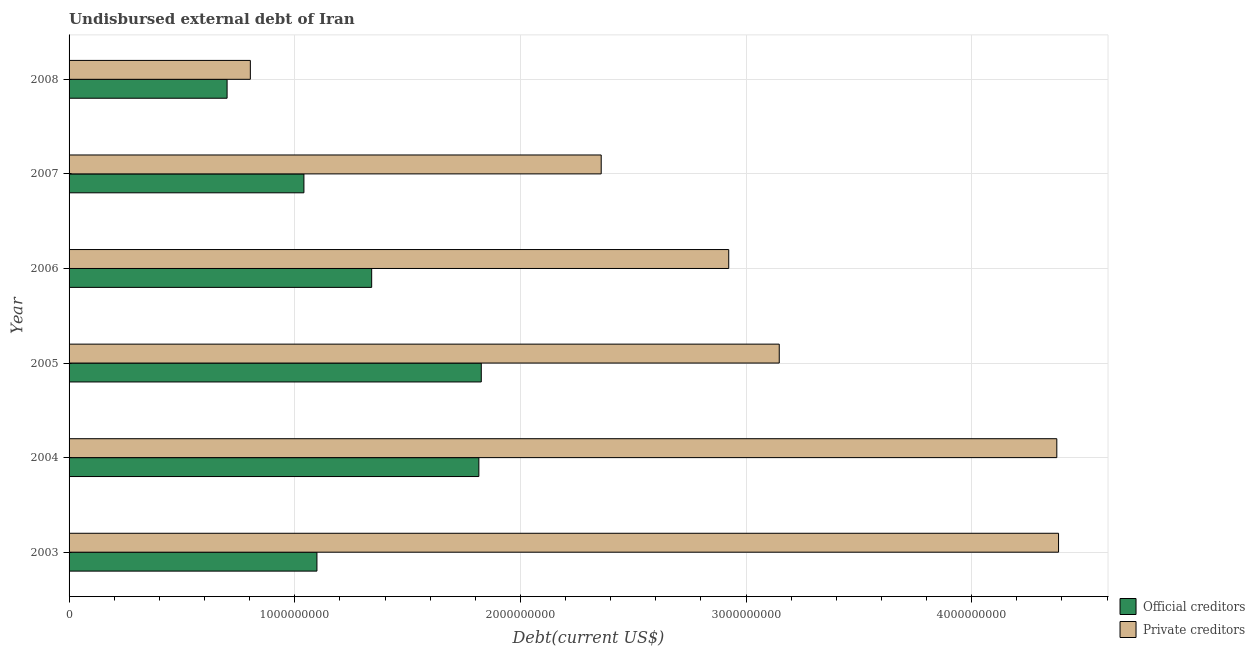How many different coloured bars are there?
Keep it short and to the point. 2. How many groups of bars are there?
Your answer should be compact. 6. Are the number of bars per tick equal to the number of legend labels?
Ensure brevity in your answer.  Yes. Are the number of bars on each tick of the Y-axis equal?
Ensure brevity in your answer.  Yes. How many bars are there on the 4th tick from the top?
Give a very brief answer. 2. What is the label of the 6th group of bars from the top?
Your answer should be compact. 2003. In how many cases, is the number of bars for a given year not equal to the number of legend labels?
Provide a succinct answer. 0. What is the undisbursed external debt of private creditors in 2007?
Ensure brevity in your answer.  2.36e+09. Across all years, what is the maximum undisbursed external debt of official creditors?
Give a very brief answer. 1.83e+09. Across all years, what is the minimum undisbursed external debt of private creditors?
Keep it short and to the point. 8.03e+08. What is the total undisbursed external debt of official creditors in the graph?
Your answer should be very brief. 7.82e+09. What is the difference between the undisbursed external debt of private creditors in 2006 and that in 2008?
Provide a succinct answer. 2.12e+09. What is the difference between the undisbursed external debt of official creditors in 2006 and the undisbursed external debt of private creditors in 2008?
Your answer should be very brief. 5.38e+08. What is the average undisbursed external debt of official creditors per year?
Your answer should be compact. 1.30e+09. In the year 2007, what is the difference between the undisbursed external debt of official creditors and undisbursed external debt of private creditors?
Ensure brevity in your answer.  -1.32e+09. In how many years, is the undisbursed external debt of official creditors greater than 800000000 US$?
Your response must be concise. 5. What is the ratio of the undisbursed external debt of official creditors in 2006 to that in 2008?
Provide a succinct answer. 1.92. Is the undisbursed external debt of private creditors in 2003 less than that in 2004?
Ensure brevity in your answer.  No. Is the difference between the undisbursed external debt of official creditors in 2005 and 2006 greater than the difference between the undisbursed external debt of private creditors in 2005 and 2006?
Offer a terse response. Yes. What is the difference between the highest and the second highest undisbursed external debt of official creditors?
Keep it short and to the point. 1.07e+07. What is the difference between the highest and the lowest undisbursed external debt of official creditors?
Your response must be concise. 1.13e+09. What does the 1st bar from the top in 2005 represents?
Offer a terse response. Private creditors. What does the 1st bar from the bottom in 2008 represents?
Offer a terse response. Official creditors. How many bars are there?
Make the answer very short. 12. Are all the bars in the graph horizontal?
Offer a terse response. Yes. Are the values on the major ticks of X-axis written in scientific E-notation?
Your answer should be very brief. No. Does the graph contain grids?
Provide a short and direct response. Yes. Where does the legend appear in the graph?
Your response must be concise. Bottom right. How many legend labels are there?
Your answer should be very brief. 2. What is the title of the graph?
Ensure brevity in your answer.  Undisbursed external debt of Iran. Does "From production" appear as one of the legend labels in the graph?
Your response must be concise. No. What is the label or title of the X-axis?
Make the answer very short. Debt(current US$). What is the Debt(current US$) of Official creditors in 2003?
Offer a very short reply. 1.10e+09. What is the Debt(current US$) of Private creditors in 2003?
Offer a very short reply. 4.38e+09. What is the Debt(current US$) of Official creditors in 2004?
Your answer should be very brief. 1.82e+09. What is the Debt(current US$) of Private creditors in 2004?
Ensure brevity in your answer.  4.38e+09. What is the Debt(current US$) in Official creditors in 2005?
Your answer should be compact. 1.83e+09. What is the Debt(current US$) in Private creditors in 2005?
Provide a succinct answer. 3.15e+09. What is the Debt(current US$) of Official creditors in 2006?
Your answer should be very brief. 1.34e+09. What is the Debt(current US$) of Private creditors in 2006?
Give a very brief answer. 2.92e+09. What is the Debt(current US$) of Official creditors in 2007?
Your answer should be compact. 1.04e+09. What is the Debt(current US$) of Private creditors in 2007?
Your answer should be very brief. 2.36e+09. What is the Debt(current US$) in Official creditors in 2008?
Make the answer very short. 7.00e+08. What is the Debt(current US$) of Private creditors in 2008?
Provide a short and direct response. 8.03e+08. Across all years, what is the maximum Debt(current US$) of Official creditors?
Your response must be concise. 1.83e+09. Across all years, what is the maximum Debt(current US$) of Private creditors?
Your answer should be compact. 4.38e+09. Across all years, what is the minimum Debt(current US$) in Official creditors?
Offer a very short reply. 7.00e+08. Across all years, what is the minimum Debt(current US$) in Private creditors?
Your response must be concise. 8.03e+08. What is the total Debt(current US$) of Official creditors in the graph?
Ensure brevity in your answer.  7.82e+09. What is the total Debt(current US$) of Private creditors in the graph?
Provide a succinct answer. 1.80e+1. What is the difference between the Debt(current US$) of Official creditors in 2003 and that in 2004?
Provide a succinct answer. -7.18e+08. What is the difference between the Debt(current US$) in Private creditors in 2003 and that in 2004?
Give a very brief answer. 7.67e+06. What is the difference between the Debt(current US$) of Official creditors in 2003 and that in 2005?
Your response must be concise. -7.28e+08. What is the difference between the Debt(current US$) of Private creditors in 2003 and that in 2005?
Provide a short and direct response. 1.24e+09. What is the difference between the Debt(current US$) of Official creditors in 2003 and that in 2006?
Your response must be concise. -2.43e+08. What is the difference between the Debt(current US$) in Private creditors in 2003 and that in 2006?
Your response must be concise. 1.46e+09. What is the difference between the Debt(current US$) of Official creditors in 2003 and that in 2007?
Provide a short and direct response. 5.76e+07. What is the difference between the Debt(current US$) in Private creditors in 2003 and that in 2007?
Your response must be concise. 2.03e+09. What is the difference between the Debt(current US$) in Official creditors in 2003 and that in 2008?
Your answer should be compact. 3.98e+08. What is the difference between the Debt(current US$) in Private creditors in 2003 and that in 2008?
Provide a succinct answer. 3.58e+09. What is the difference between the Debt(current US$) in Official creditors in 2004 and that in 2005?
Keep it short and to the point. -1.07e+07. What is the difference between the Debt(current US$) in Private creditors in 2004 and that in 2005?
Your answer should be compact. 1.23e+09. What is the difference between the Debt(current US$) of Official creditors in 2004 and that in 2006?
Your answer should be compact. 4.75e+08. What is the difference between the Debt(current US$) of Private creditors in 2004 and that in 2006?
Your answer should be compact. 1.45e+09. What is the difference between the Debt(current US$) in Official creditors in 2004 and that in 2007?
Give a very brief answer. 7.75e+08. What is the difference between the Debt(current US$) of Private creditors in 2004 and that in 2007?
Keep it short and to the point. 2.02e+09. What is the difference between the Debt(current US$) in Official creditors in 2004 and that in 2008?
Provide a short and direct response. 1.12e+09. What is the difference between the Debt(current US$) in Private creditors in 2004 and that in 2008?
Your answer should be very brief. 3.57e+09. What is the difference between the Debt(current US$) in Official creditors in 2005 and that in 2006?
Offer a very short reply. 4.86e+08. What is the difference between the Debt(current US$) of Private creditors in 2005 and that in 2006?
Offer a very short reply. 2.24e+08. What is the difference between the Debt(current US$) of Official creditors in 2005 and that in 2007?
Your answer should be very brief. 7.86e+08. What is the difference between the Debt(current US$) of Private creditors in 2005 and that in 2007?
Your answer should be very brief. 7.89e+08. What is the difference between the Debt(current US$) of Official creditors in 2005 and that in 2008?
Your answer should be very brief. 1.13e+09. What is the difference between the Debt(current US$) in Private creditors in 2005 and that in 2008?
Provide a succinct answer. 2.34e+09. What is the difference between the Debt(current US$) in Official creditors in 2006 and that in 2007?
Your response must be concise. 3.00e+08. What is the difference between the Debt(current US$) of Private creditors in 2006 and that in 2007?
Your response must be concise. 5.65e+08. What is the difference between the Debt(current US$) of Official creditors in 2006 and that in 2008?
Make the answer very short. 6.41e+08. What is the difference between the Debt(current US$) of Private creditors in 2006 and that in 2008?
Your answer should be very brief. 2.12e+09. What is the difference between the Debt(current US$) in Official creditors in 2007 and that in 2008?
Give a very brief answer. 3.41e+08. What is the difference between the Debt(current US$) in Private creditors in 2007 and that in 2008?
Provide a succinct answer. 1.55e+09. What is the difference between the Debt(current US$) in Official creditors in 2003 and the Debt(current US$) in Private creditors in 2004?
Your answer should be compact. -3.28e+09. What is the difference between the Debt(current US$) in Official creditors in 2003 and the Debt(current US$) in Private creditors in 2005?
Make the answer very short. -2.05e+09. What is the difference between the Debt(current US$) in Official creditors in 2003 and the Debt(current US$) in Private creditors in 2006?
Provide a succinct answer. -1.82e+09. What is the difference between the Debt(current US$) of Official creditors in 2003 and the Debt(current US$) of Private creditors in 2007?
Your response must be concise. -1.26e+09. What is the difference between the Debt(current US$) in Official creditors in 2003 and the Debt(current US$) in Private creditors in 2008?
Your answer should be very brief. 2.95e+08. What is the difference between the Debt(current US$) in Official creditors in 2004 and the Debt(current US$) in Private creditors in 2005?
Provide a succinct answer. -1.33e+09. What is the difference between the Debt(current US$) of Official creditors in 2004 and the Debt(current US$) of Private creditors in 2006?
Your answer should be very brief. -1.11e+09. What is the difference between the Debt(current US$) of Official creditors in 2004 and the Debt(current US$) of Private creditors in 2007?
Your answer should be very brief. -5.42e+08. What is the difference between the Debt(current US$) of Official creditors in 2004 and the Debt(current US$) of Private creditors in 2008?
Provide a succinct answer. 1.01e+09. What is the difference between the Debt(current US$) of Official creditors in 2005 and the Debt(current US$) of Private creditors in 2006?
Make the answer very short. -1.10e+09. What is the difference between the Debt(current US$) of Official creditors in 2005 and the Debt(current US$) of Private creditors in 2007?
Give a very brief answer. -5.31e+08. What is the difference between the Debt(current US$) in Official creditors in 2005 and the Debt(current US$) in Private creditors in 2008?
Keep it short and to the point. 1.02e+09. What is the difference between the Debt(current US$) of Official creditors in 2006 and the Debt(current US$) of Private creditors in 2007?
Provide a short and direct response. -1.02e+09. What is the difference between the Debt(current US$) of Official creditors in 2006 and the Debt(current US$) of Private creditors in 2008?
Provide a succinct answer. 5.38e+08. What is the difference between the Debt(current US$) of Official creditors in 2007 and the Debt(current US$) of Private creditors in 2008?
Offer a terse response. 2.37e+08. What is the average Debt(current US$) in Official creditors per year?
Ensure brevity in your answer.  1.30e+09. What is the average Debt(current US$) in Private creditors per year?
Ensure brevity in your answer.  3.00e+09. In the year 2003, what is the difference between the Debt(current US$) of Official creditors and Debt(current US$) of Private creditors?
Make the answer very short. -3.29e+09. In the year 2004, what is the difference between the Debt(current US$) in Official creditors and Debt(current US$) in Private creditors?
Ensure brevity in your answer.  -2.56e+09. In the year 2005, what is the difference between the Debt(current US$) in Official creditors and Debt(current US$) in Private creditors?
Your answer should be very brief. -1.32e+09. In the year 2006, what is the difference between the Debt(current US$) in Official creditors and Debt(current US$) in Private creditors?
Give a very brief answer. -1.58e+09. In the year 2007, what is the difference between the Debt(current US$) in Official creditors and Debt(current US$) in Private creditors?
Your answer should be compact. -1.32e+09. In the year 2008, what is the difference between the Debt(current US$) in Official creditors and Debt(current US$) in Private creditors?
Your answer should be compact. -1.03e+08. What is the ratio of the Debt(current US$) in Official creditors in 2003 to that in 2004?
Make the answer very short. 0.6. What is the ratio of the Debt(current US$) in Official creditors in 2003 to that in 2005?
Your answer should be very brief. 0.6. What is the ratio of the Debt(current US$) in Private creditors in 2003 to that in 2005?
Your answer should be very brief. 1.39. What is the ratio of the Debt(current US$) in Official creditors in 2003 to that in 2006?
Your response must be concise. 0.82. What is the ratio of the Debt(current US$) of Official creditors in 2003 to that in 2007?
Your answer should be compact. 1.06. What is the ratio of the Debt(current US$) in Private creditors in 2003 to that in 2007?
Your answer should be very brief. 1.86. What is the ratio of the Debt(current US$) in Official creditors in 2003 to that in 2008?
Your answer should be compact. 1.57. What is the ratio of the Debt(current US$) of Private creditors in 2003 to that in 2008?
Offer a very short reply. 5.46. What is the ratio of the Debt(current US$) of Private creditors in 2004 to that in 2005?
Your answer should be compact. 1.39. What is the ratio of the Debt(current US$) of Official creditors in 2004 to that in 2006?
Make the answer very short. 1.35. What is the ratio of the Debt(current US$) in Private creditors in 2004 to that in 2006?
Offer a very short reply. 1.5. What is the ratio of the Debt(current US$) in Official creditors in 2004 to that in 2007?
Give a very brief answer. 1.74. What is the ratio of the Debt(current US$) of Private creditors in 2004 to that in 2007?
Provide a short and direct response. 1.86. What is the ratio of the Debt(current US$) in Official creditors in 2004 to that in 2008?
Your answer should be very brief. 2.59. What is the ratio of the Debt(current US$) of Private creditors in 2004 to that in 2008?
Your response must be concise. 5.45. What is the ratio of the Debt(current US$) of Official creditors in 2005 to that in 2006?
Offer a very short reply. 1.36. What is the ratio of the Debt(current US$) in Private creditors in 2005 to that in 2006?
Give a very brief answer. 1.08. What is the ratio of the Debt(current US$) in Official creditors in 2005 to that in 2007?
Ensure brevity in your answer.  1.76. What is the ratio of the Debt(current US$) in Private creditors in 2005 to that in 2007?
Give a very brief answer. 1.33. What is the ratio of the Debt(current US$) of Official creditors in 2005 to that in 2008?
Your response must be concise. 2.61. What is the ratio of the Debt(current US$) in Private creditors in 2005 to that in 2008?
Offer a terse response. 3.92. What is the ratio of the Debt(current US$) of Official creditors in 2006 to that in 2007?
Your answer should be compact. 1.29. What is the ratio of the Debt(current US$) of Private creditors in 2006 to that in 2007?
Provide a succinct answer. 1.24. What is the ratio of the Debt(current US$) of Official creditors in 2006 to that in 2008?
Your answer should be compact. 1.92. What is the ratio of the Debt(current US$) of Private creditors in 2006 to that in 2008?
Provide a succinct answer. 3.64. What is the ratio of the Debt(current US$) in Official creditors in 2007 to that in 2008?
Offer a terse response. 1.49. What is the ratio of the Debt(current US$) of Private creditors in 2007 to that in 2008?
Your answer should be compact. 2.94. What is the difference between the highest and the second highest Debt(current US$) in Official creditors?
Provide a short and direct response. 1.07e+07. What is the difference between the highest and the second highest Debt(current US$) of Private creditors?
Offer a very short reply. 7.67e+06. What is the difference between the highest and the lowest Debt(current US$) in Official creditors?
Provide a short and direct response. 1.13e+09. What is the difference between the highest and the lowest Debt(current US$) in Private creditors?
Offer a terse response. 3.58e+09. 